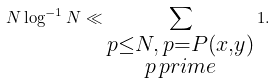Convert formula to latex. <formula><loc_0><loc_0><loc_500><loc_500>N \log ^ { - 1 } N \ll \sum _ { \substack { p \leq N , \, p = P ( x , y ) \\ p \, p r i m e } } 1 .</formula> 